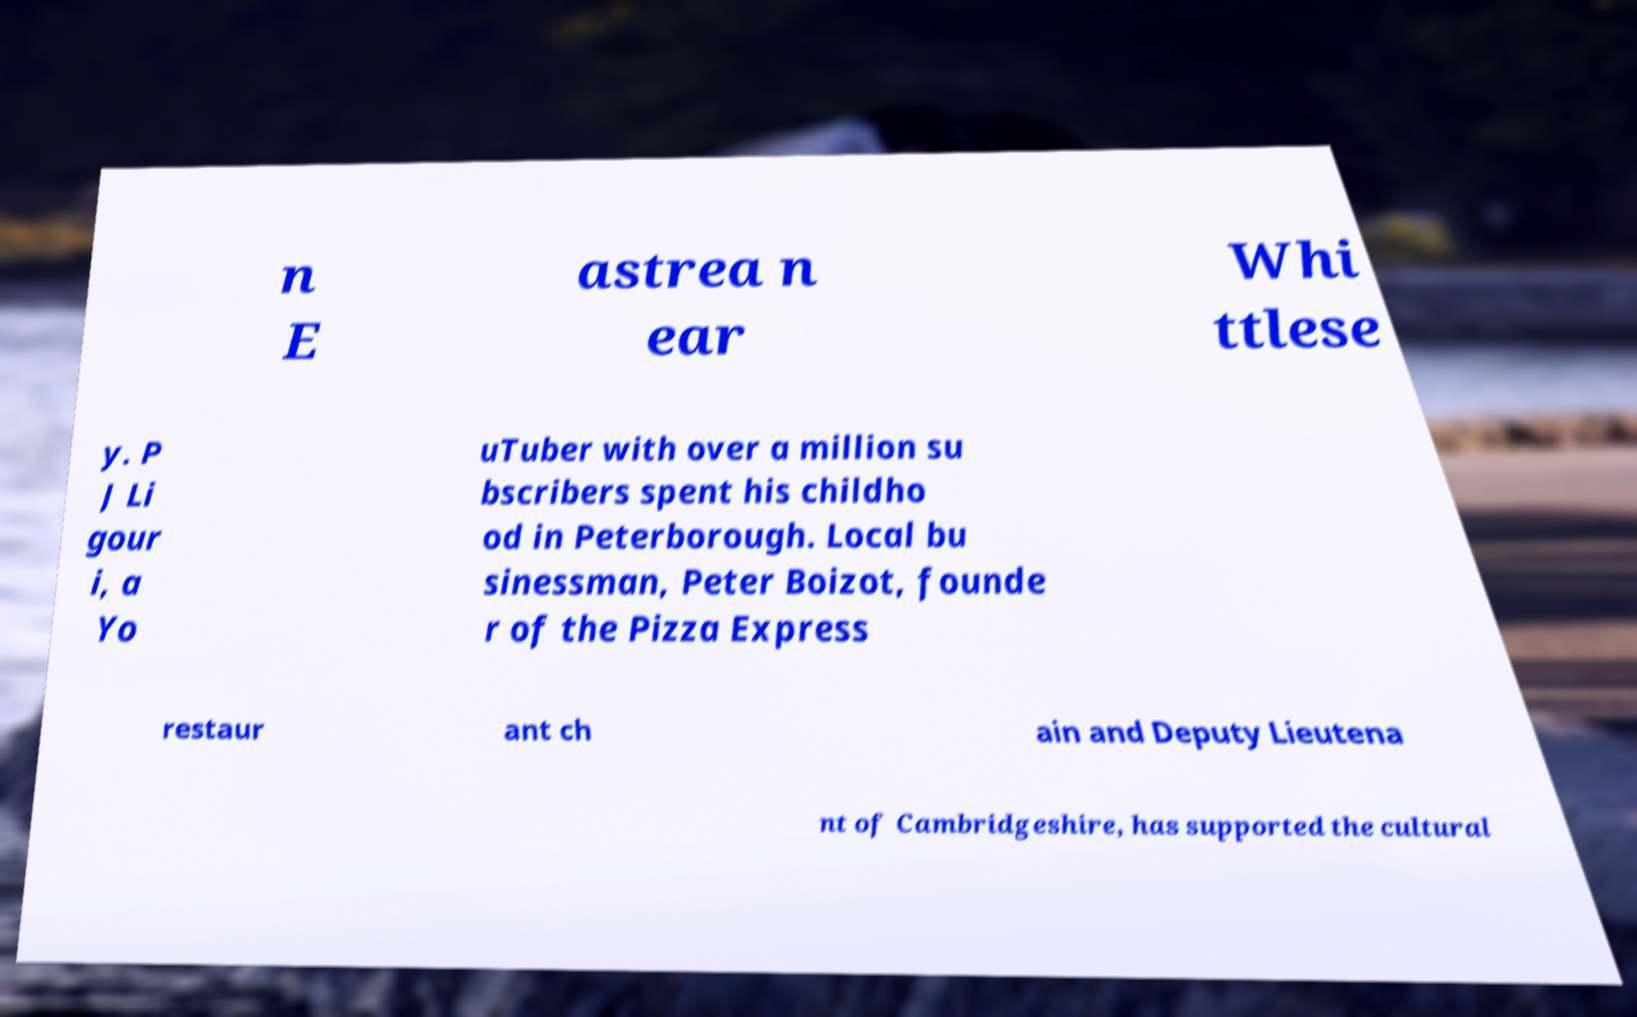I need the written content from this picture converted into text. Can you do that? n E astrea n ear Whi ttlese y. P J Li gour i, a Yo uTuber with over a million su bscribers spent his childho od in Peterborough. Local bu sinessman, Peter Boizot, founde r of the Pizza Express restaur ant ch ain and Deputy Lieutena nt of Cambridgeshire, has supported the cultural 